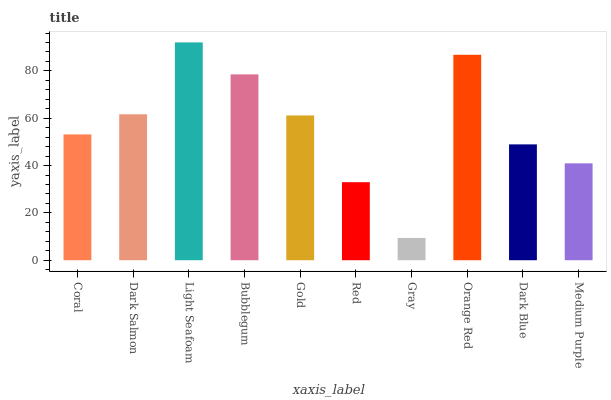Is Gray the minimum?
Answer yes or no. Yes. Is Light Seafoam the maximum?
Answer yes or no. Yes. Is Dark Salmon the minimum?
Answer yes or no. No. Is Dark Salmon the maximum?
Answer yes or no. No. Is Dark Salmon greater than Coral?
Answer yes or no. Yes. Is Coral less than Dark Salmon?
Answer yes or no. Yes. Is Coral greater than Dark Salmon?
Answer yes or no. No. Is Dark Salmon less than Coral?
Answer yes or no. No. Is Gold the high median?
Answer yes or no. Yes. Is Coral the low median?
Answer yes or no. Yes. Is Red the high median?
Answer yes or no. No. Is Orange Red the low median?
Answer yes or no. No. 